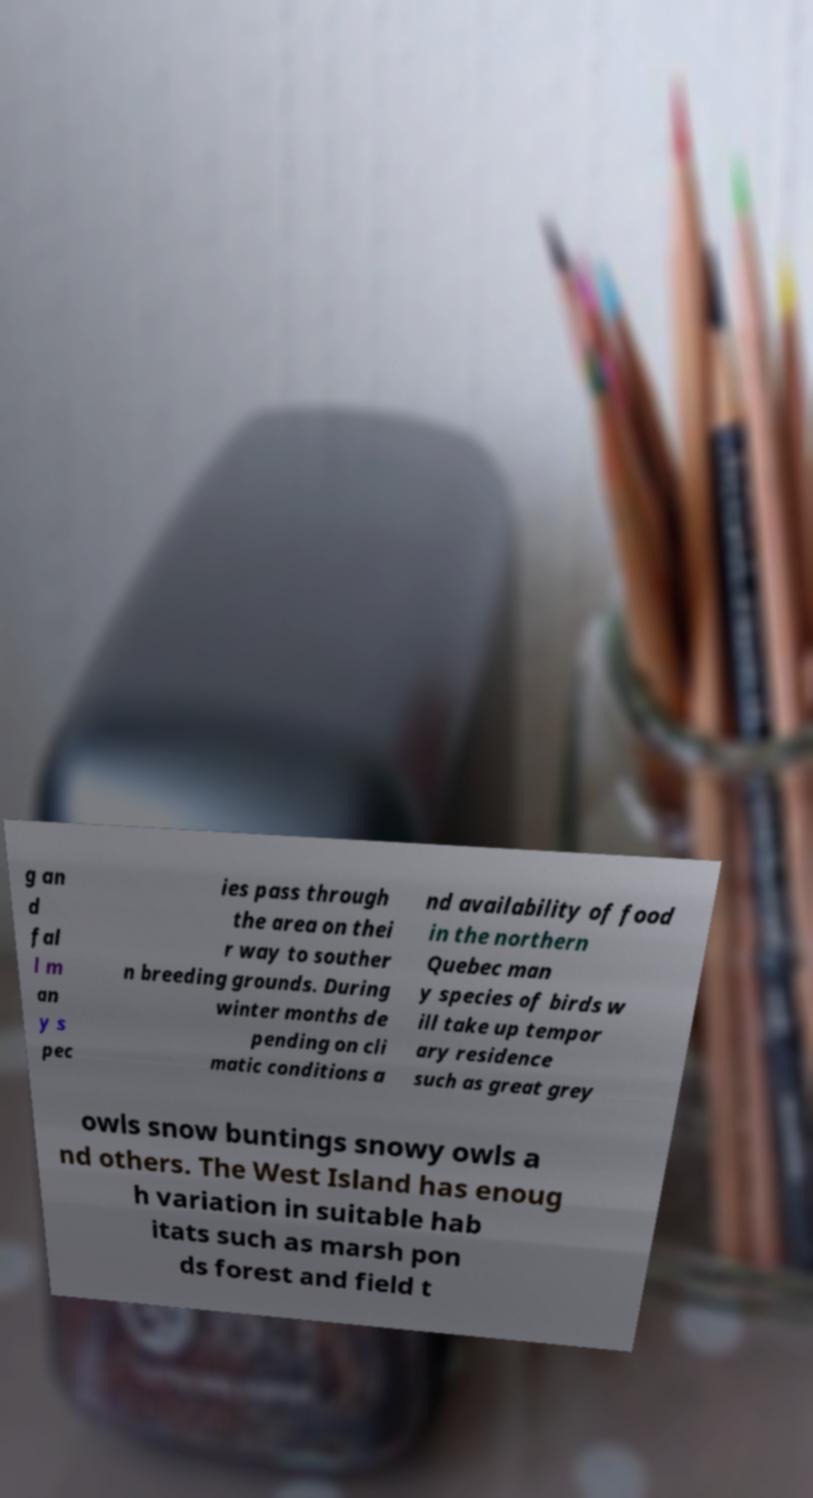Could you extract and type out the text from this image? g an d fal l m an y s pec ies pass through the area on thei r way to souther n breeding grounds. During winter months de pending on cli matic conditions a nd availability of food in the northern Quebec man y species of birds w ill take up tempor ary residence such as great grey owls snow buntings snowy owls a nd others. The West Island has enoug h variation in suitable hab itats such as marsh pon ds forest and field t 